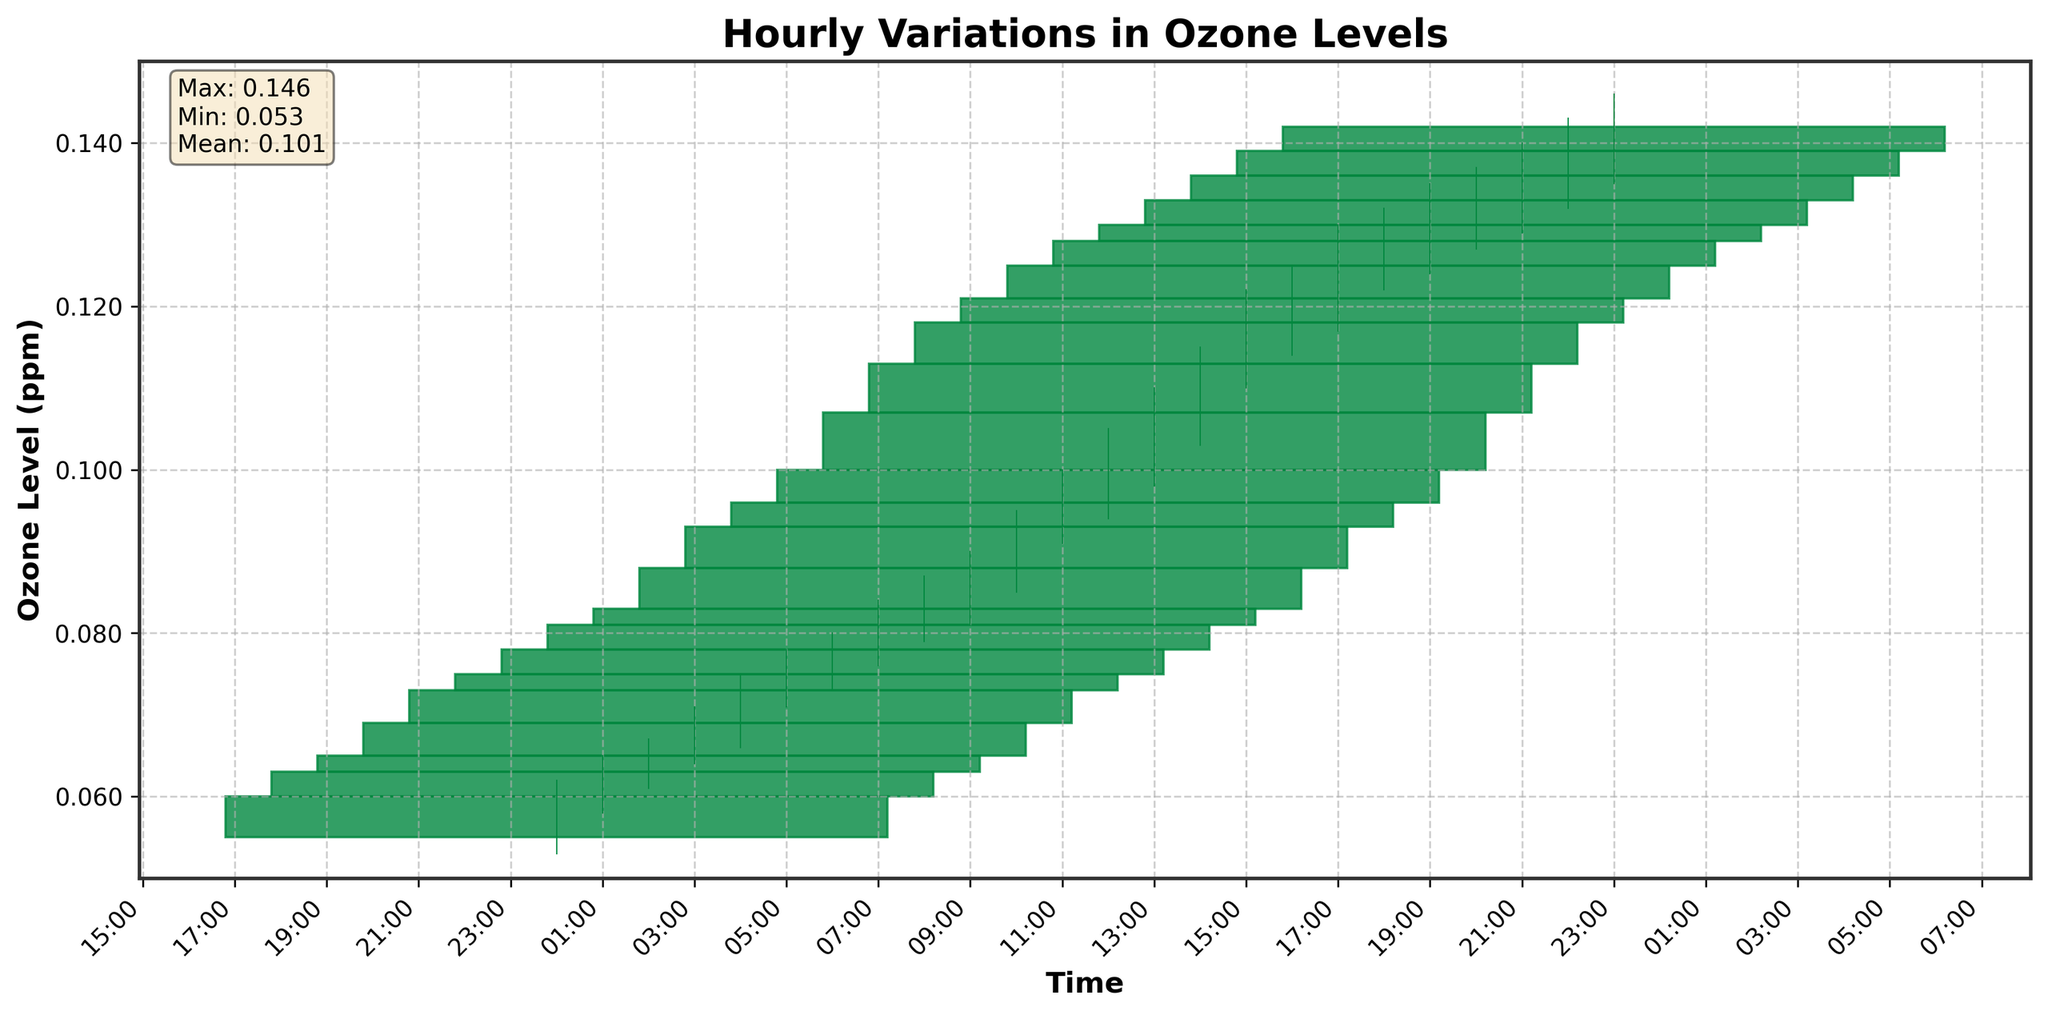What's the title of the figure? The title of the figure is located at the top center and is clearly stated in bold font.
Answer: Hourly Variations in Ozone Levels What are the units on the y-axis? The y-axis label indicates the units used to measure the ozone levels.
Answer: ppm (parts per million) Which hour had the highest peak ozone level? Observing the candlestick plot and looking at the highest point on the chart, we can determine which hour had the highest peak ozone level.
Answer: 13:00 (1 PM) What is the average closing ozone level for the entire day? To find the average closing ozone level, sum up all the closing values and divide by the number of data points. The data shows 24 closing values, and the average is computed as (0.060 + 0.063 + 0.065 + 0.069 + 0.073 + 0.075 + 0.078 + 0.081 + 0.083 + 0.088 + 0.093 + 0.096 + 0.100 + 0.107 + 0.113 + 0.118 + 0.121 + 0.125 + 0.128 + 0.130 + 0.133 + 0.136 + 0.139 + 0.142)/24, which is approximately 0.099 ppm.
Answer: 0.099 ppm Compare the first and last hour: did the ozone level increase, decrease, or stay the same? To compare the first and last hour, look at the closing values at 00:00 and 23:00. The value at 00:00 is 0.060 and at 23:00 is 0.142.
Answer: Increase Did the ozone level ever decrease during any hour, and if so, when? To determine if the ozone level ever decreased, observe the closing values for consecutive hours and identify any decreases. Between 16:00 and 17:00, there's a drop from 0.121 to 0.125.
Answer: Yes, between 16:00 and 17:00 What is the range of the ozone levels throughout the day? The range is calculated by subtracting the minimum recorded value (low) from the maximum recorded value (high). The minimum value seen is 0.053, and the maximum is 0.146. Thus, 0.146 - 0.053 = 0.093 ppm.
Answer: 0.093 ppm Between which hours did the largest single-hour increase in closing ozone levels occur? To find the largest single-hour increase, look for the biggest difference between consecutive closing values. The largest increase is from 12:00 (0.100) to 13:00 (0.107), which is an increase of 0.007 ppm.
Answer: 12:00 to 13:00 What is the median closing value for the day? To find the median closing value, we need to list all the closing values in ascending order and determine the middle value. The middle values are approximately 0.097 and 0.100 (after sorting), thus the median is (0.097+0.100)/2.
Answer: 0.099 What were the ozone levels (open, close) at 15:00? Refer to the candlestick representing 15:00; the opening and closing values are visible.
Answer: Open: 0.113, Close: 0.118 